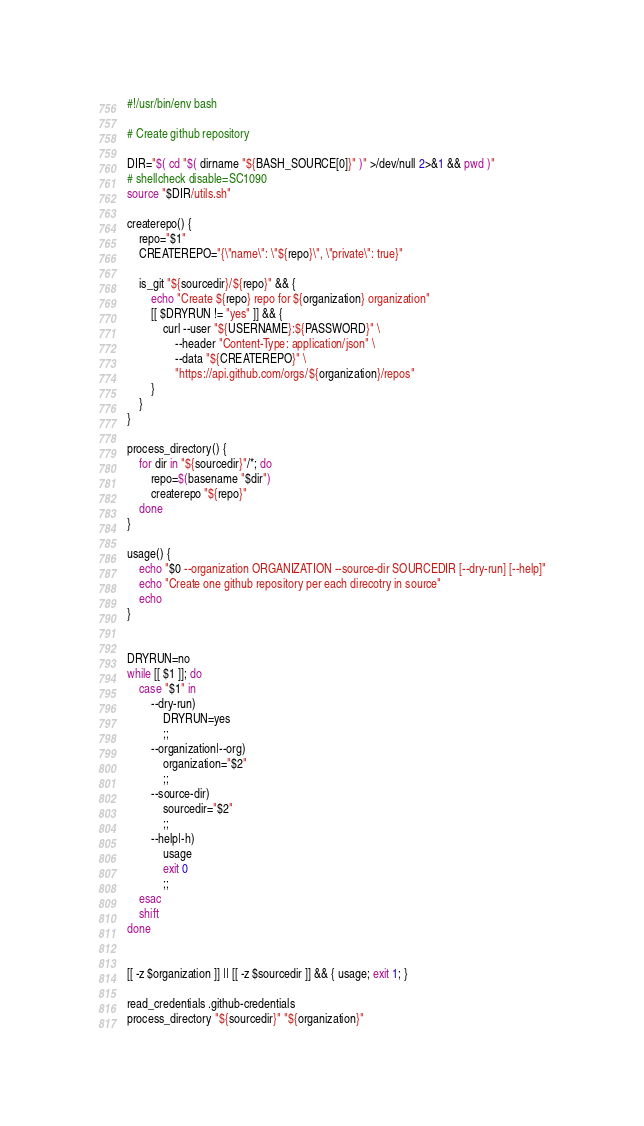Convert code to text. <code><loc_0><loc_0><loc_500><loc_500><_Bash_>#!/usr/bin/env bash

# Create github repository

DIR="$( cd "$( dirname "${BASH_SOURCE[0]}" )" >/dev/null 2>&1 && pwd )"
# shellcheck disable=SC1090
source "$DIR/utils.sh"

createrepo() {
    repo="$1"
    CREATEREPO="{\"name\": \"${repo}\", \"private\": true}"

    is_git "${sourcedir}/${repo}" && {
        echo "Create ${repo} repo for ${organization} organization"
        [[ $DRYRUN != "yes" ]] && {
            curl --user "${USERNAME}:${PASSWORD}" \
                --header "Content-Type: application/json" \
                --data "${CREATEREPO}" \
                "https://api.github.com/orgs/${organization}/repos"
        }
    }
}

process_directory() {
    for dir in "${sourcedir}"/*; do
        repo=$(basename "$dir")
        createrepo "${repo}"
    done
}

usage() {
    echo "$0 --organization ORGANIZATION --source-dir SOURCEDIR [--dry-run] [--help]"
    echo "Create one github repository per each direcotry in source"
    echo
}


DRYRUN=no
while [[ $1 ]]; do
    case "$1" in
        --dry-run)
            DRYRUN=yes
            ;;
        --organization|--org)
            organization="$2"
            ;;
        --source-dir)
            sourcedir="$2"
            ;;
        --help|-h)
            usage
            exit 0
            ;;
    esac
    shift
done


[[ -z $organization ]] || [[ -z $sourcedir ]] && { usage; exit 1; }

read_credentials .github-credentials
process_directory "${sourcedir}" "${organization}"
</code> 